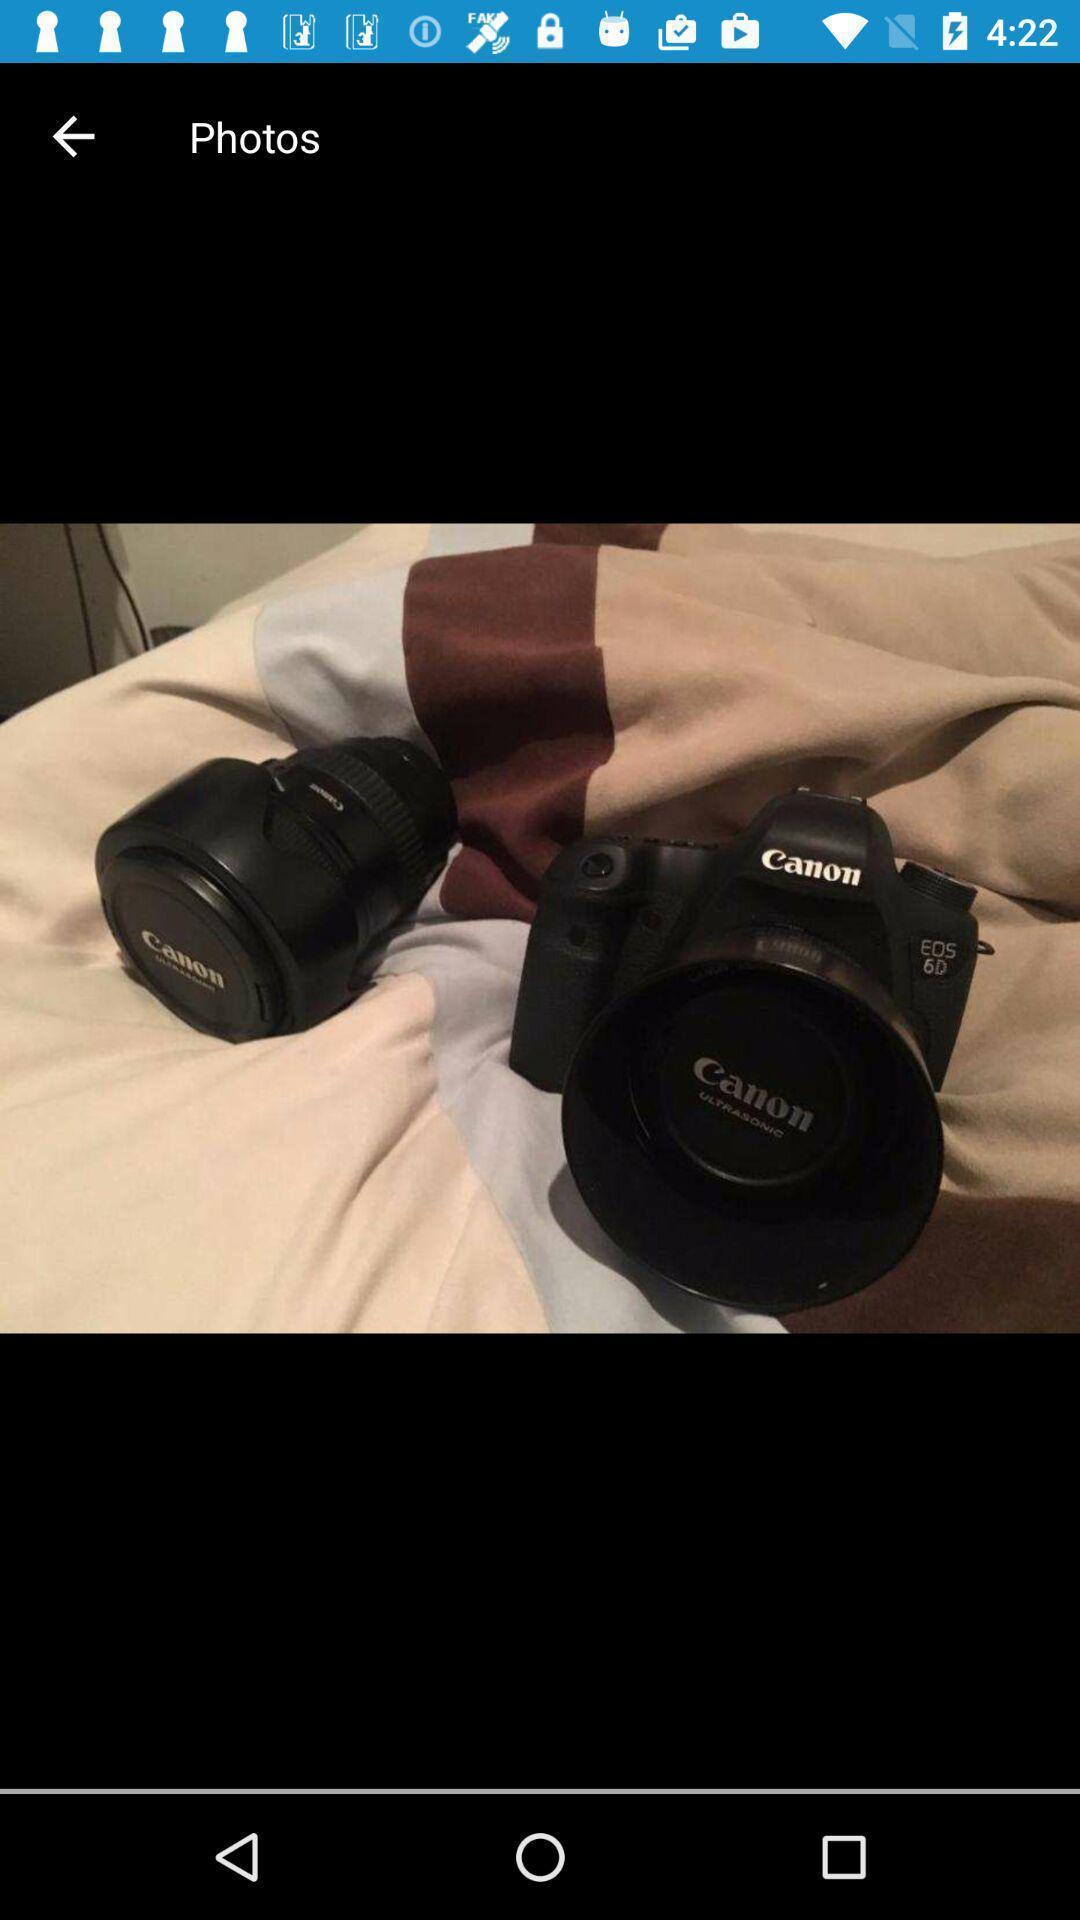Describe this image in words. Screen displaying the image shopping app. 